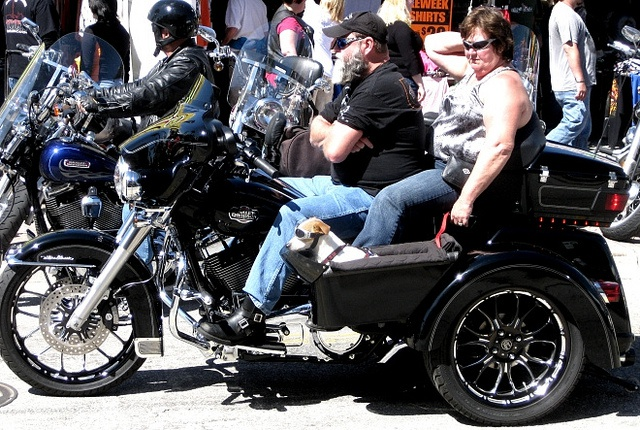Describe the objects in this image and their specific colors. I can see motorcycle in black, white, gray, and darkgray tones, motorcycle in black, gray, navy, and darkgray tones, people in black, white, gray, and lightblue tones, people in black, white, gray, and lightpink tones, and motorcycle in black, gray, and darkgray tones in this image. 